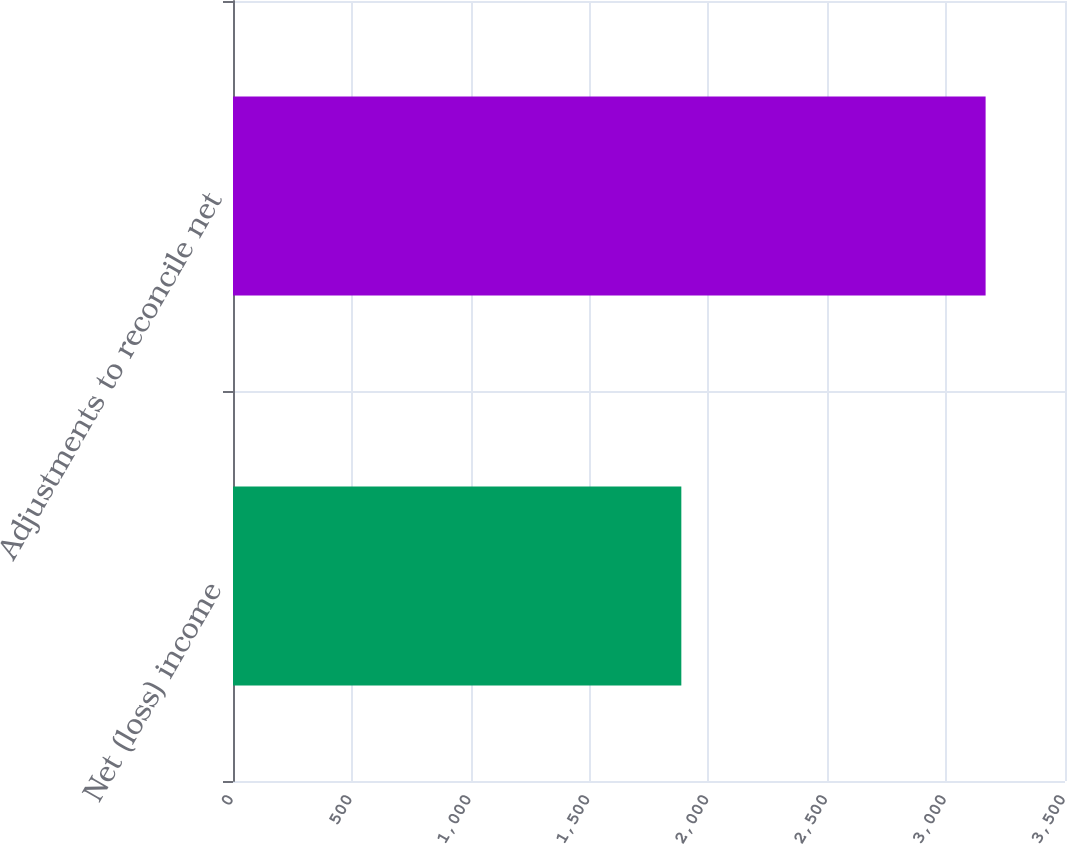Convert chart. <chart><loc_0><loc_0><loc_500><loc_500><bar_chart><fcel>Net (loss) income<fcel>Adjustments to reconcile net<nl><fcel>1886<fcel>3166<nl></chart> 